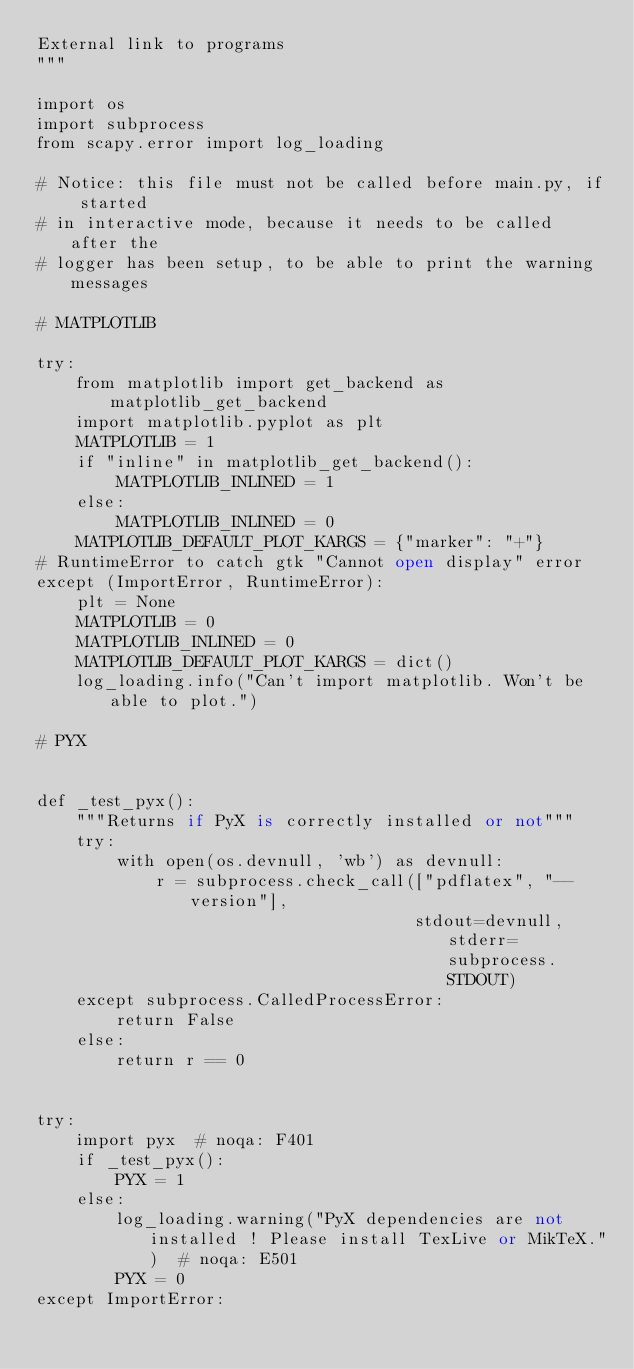<code> <loc_0><loc_0><loc_500><loc_500><_Python_>External link to programs
"""

import os
import subprocess
from scapy.error import log_loading

# Notice: this file must not be called before main.py, if started
# in interactive mode, because it needs to be called after the
# logger has been setup, to be able to print the warning messages

# MATPLOTLIB

try:
    from matplotlib import get_backend as matplotlib_get_backend
    import matplotlib.pyplot as plt
    MATPLOTLIB = 1
    if "inline" in matplotlib_get_backend():
        MATPLOTLIB_INLINED = 1
    else:
        MATPLOTLIB_INLINED = 0
    MATPLOTLIB_DEFAULT_PLOT_KARGS = {"marker": "+"}
# RuntimeError to catch gtk "Cannot open display" error
except (ImportError, RuntimeError):
    plt = None
    MATPLOTLIB = 0
    MATPLOTLIB_INLINED = 0
    MATPLOTLIB_DEFAULT_PLOT_KARGS = dict()
    log_loading.info("Can't import matplotlib. Won't be able to plot.")

# PYX


def _test_pyx():
    """Returns if PyX is correctly installed or not"""
    try:
        with open(os.devnull, 'wb') as devnull:
            r = subprocess.check_call(["pdflatex", "--version"],
                                      stdout=devnull, stderr=subprocess.STDOUT)
    except subprocess.CalledProcessError:
        return False
    else:
        return r == 0


try:
    import pyx  # noqa: F401
    if _test_pyx():
        PYX = 1
    else:
        log_loading.warning("PyX dependencies are not installed ! Please install TexLive or MikTeX.")  # noqa: E501
        PYX = 0
except ImportError:</code> 